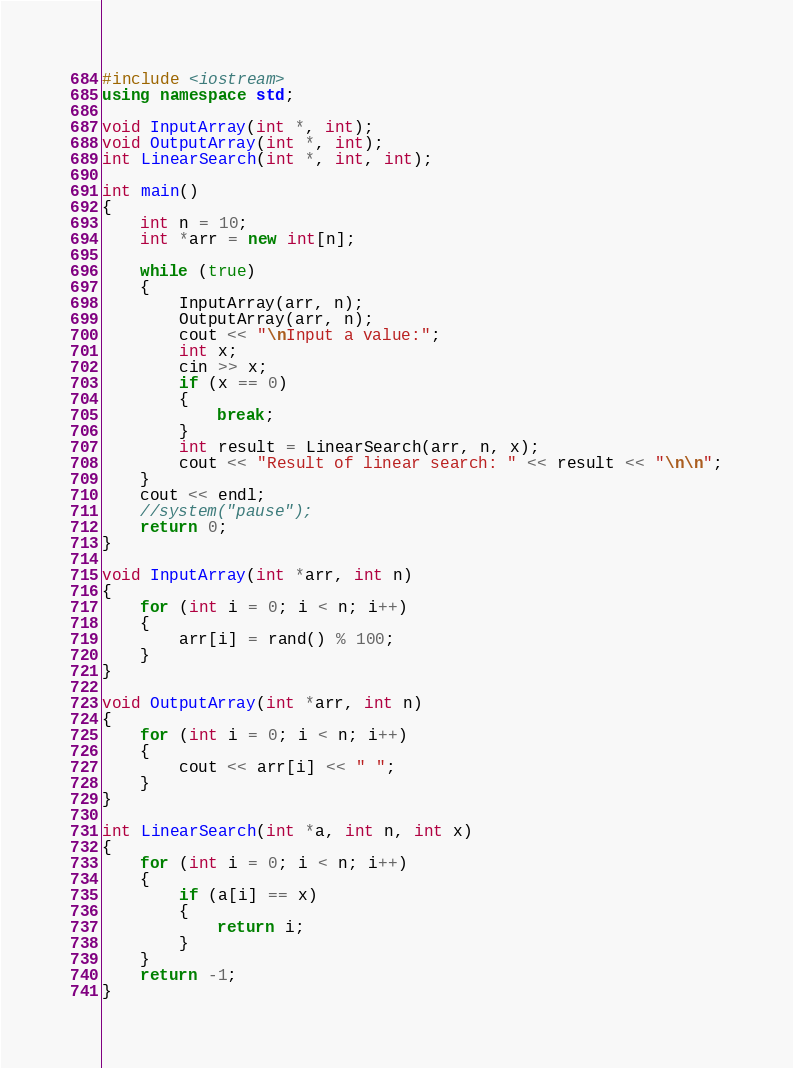<code> <loc_0><loc_0><loc_500><loc_500><_C++_>#include <iostream>
using namespace std;

void InputArray(int *, int);
void OutputArray(int *, int);
int LinearSearch(int *, int, int);

int main()
{
    int n = 10;
    int *arr = new int[n];

    while (true)
    {
        InputArray(arr, n);
        OutputArray(arr, n);
        cout << "\nInput a value:";
        int x;
        cin >> x;
        if (x == 0)
        {
            break;
        }
        int result = LinearSearch(arr, n, x);
        cout << "Result of linear search: " << result << "\n\n";
    }
    cout << endl;
    //system("pause");
    return 0;
}

void InputArray(int *arr, int n)
{
    for (int i = 0; i < n; i++)
    {
        arr[i] = rand() % 100;
    }
}

void OutputArray(int *arr, int n)
{
    for (int i = 0; i < n; i++)
    {
        cout << arr[i] << " ";
    }
}

int LinearSearch(int *a, int n, int x)
{
    for (int i = 0; i < n; i++)
    {
        if (a[i] == x)
        {
            return i;
        }
    }
    return -1;
}
</code> 